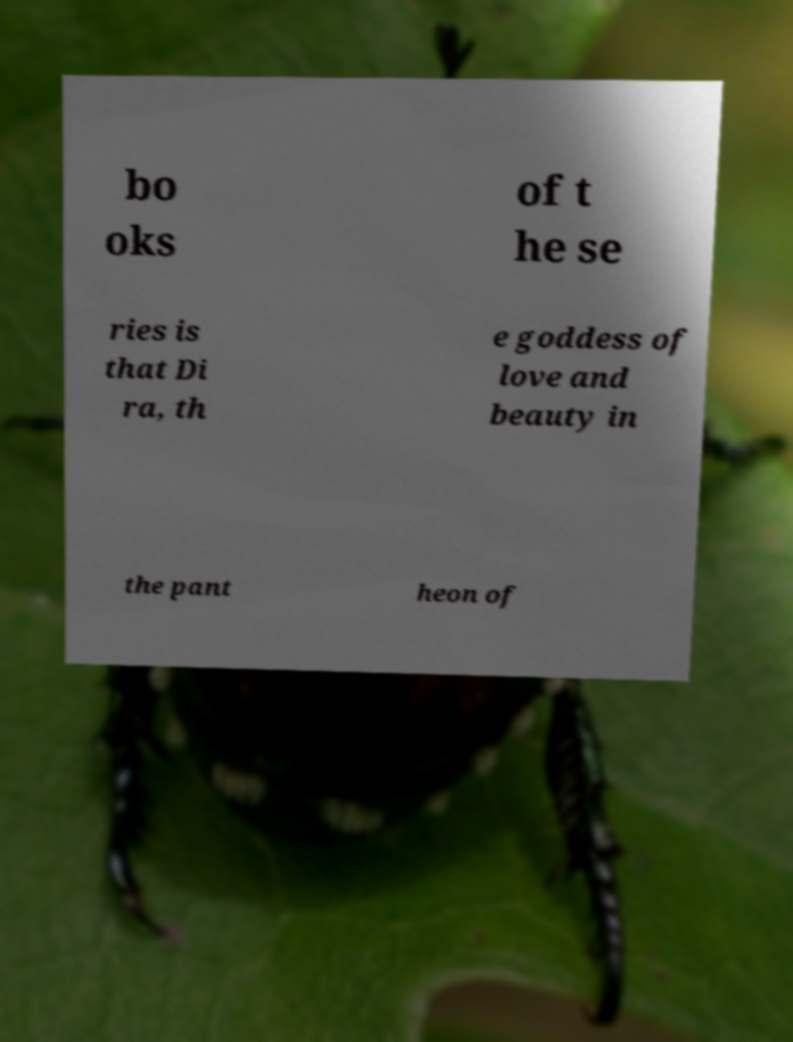I need the written content from this picture converted into text. Can you do that? bo oks of t he se ries is that Di ra, th e goddess of love and beauty in the pant heon of 